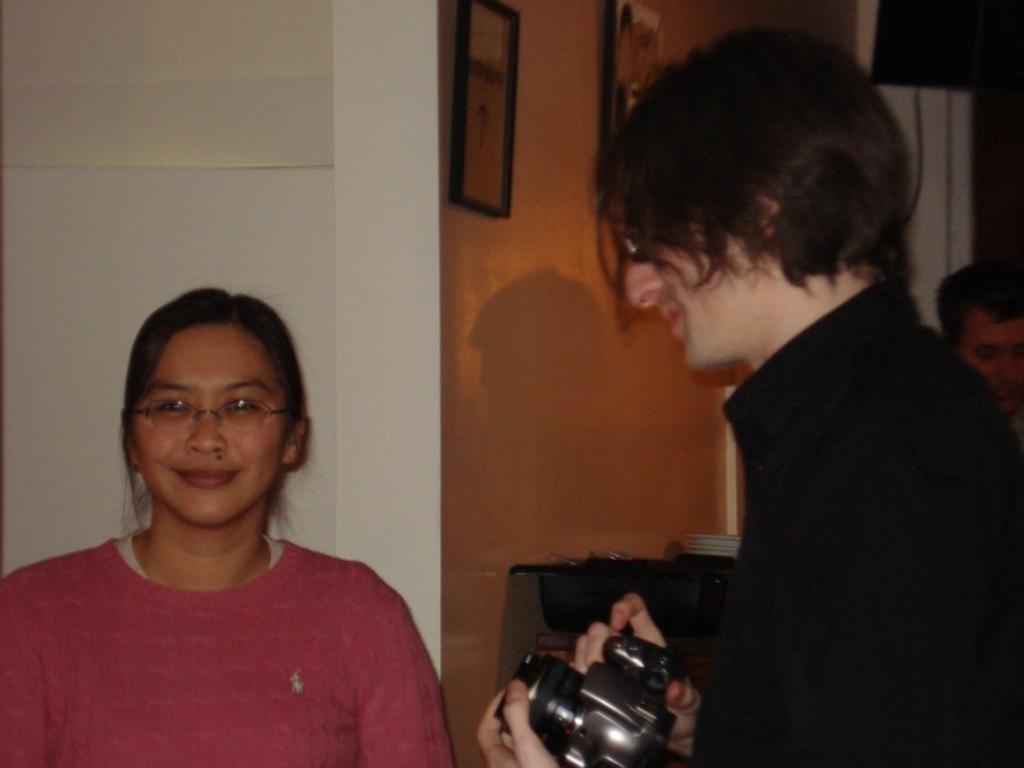Can you describe this image briefly? In this image, In the left side there is a woman standing and she is smiling, In the right side there is a man standing in black color shirt and he is holding a camera, In the background there is a white color and orange color wall and a clock in black color. 